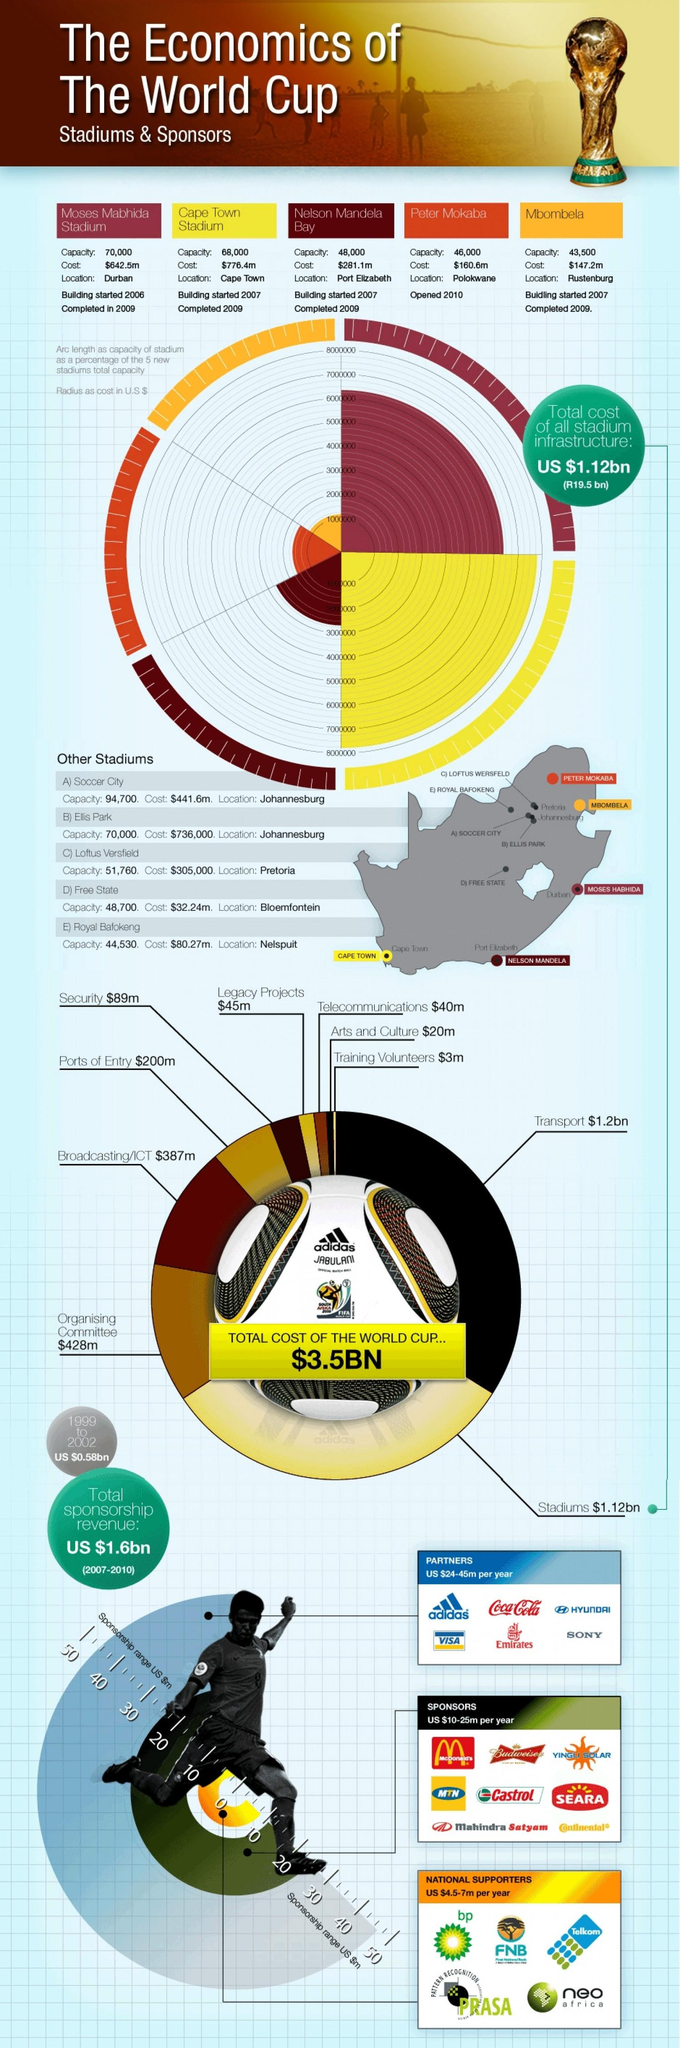Point out several critical features in this image. The stadium with the highest capacity is located in Durban. The Cape Town Stadium was the most expensive stadium to build among the ones mentioned. The stadium with a capacity of 46,000 began functioning in 2010. The Cape Town Stadium, Nelson Mandela Bay Stadium, and Mbombela Stadium were all started in 2007 and completed in 2009. 